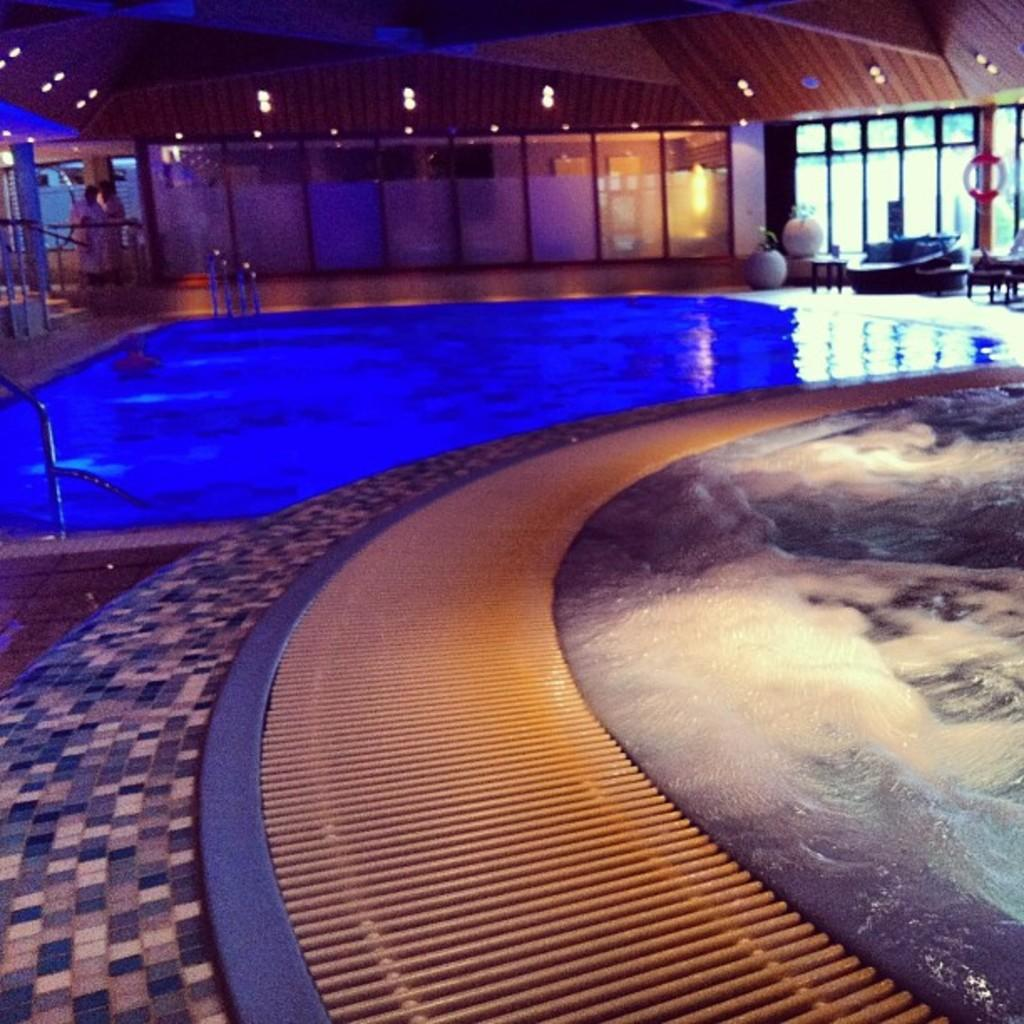What can be seen in the background of the image? In the background of the image, there are lights, plants with pots, and a floor visible. What is the main subject of the image? The image depicts a swimming pool. How many people are in the image? There are two people standing at the left side corner of the image. What type of party is being held near the swimming pool in the image? There is no indication of a party in the image; it only depicts a swimming pool and two people standing nearby. 